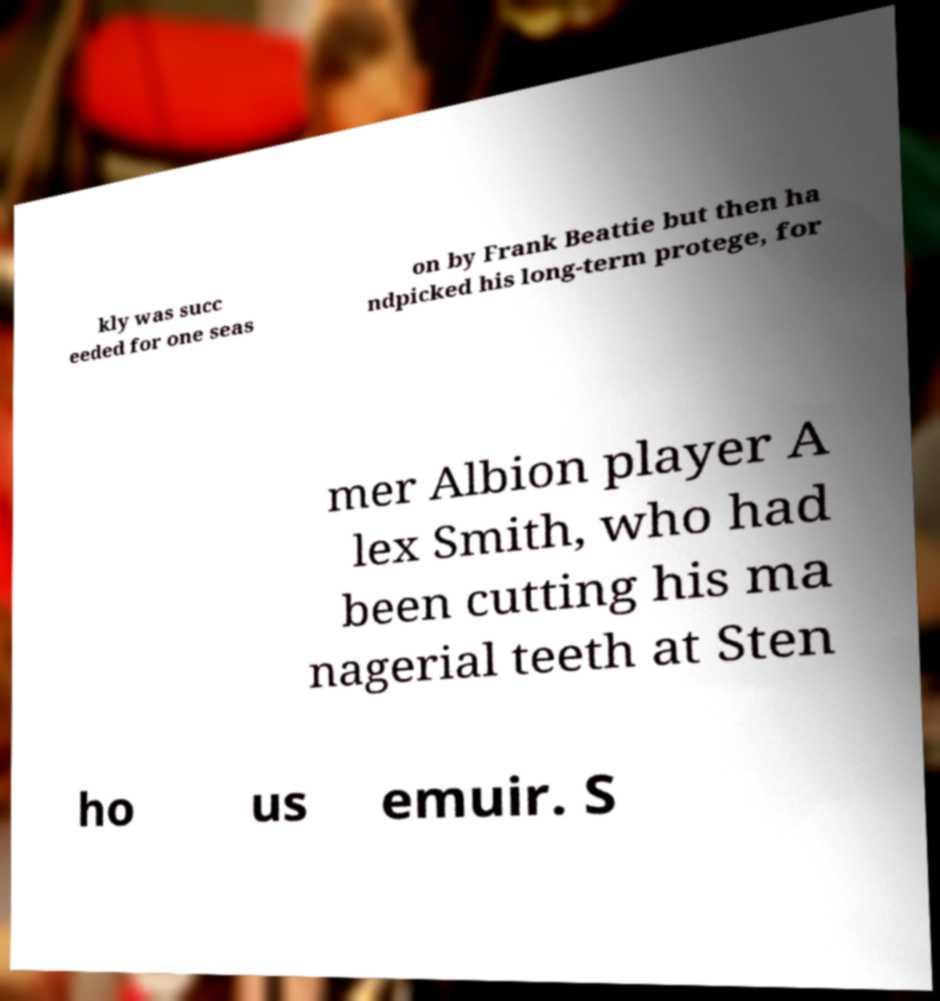I need the written content from this picture converted into text. Can you do that? kly was succ eeded for one seas on by Frank Beattie but then ha ndpicked his long-term protege, for mer Albion player A lex Smith, who had been cutting his ma nagerial teeth at Sten ho us emuir. S 